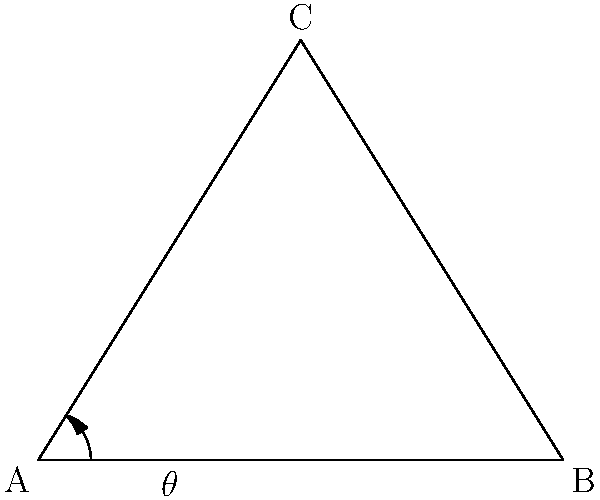In designing an optimal barricade structure, a triangular shape is proposed. The base of the triangle is 10 units long, and the height is 8 units. What is the optimal angle of inclination ($\theta$) for maximum stability against external forces? To find the optimal angle of inclination ($\theta$) for maximum stability:

1. Recognize that the angle of inclination is the angle between the base and the side of the triangle.

2. In a right-angled triangle, tangent of an angle is the ratio of the opposite side to the adjacent side.

3. Here, the height (opposite side) is 8 units, and half of the base (adjacent side) is 5 units.

4. Use the arctangent function to find the angle:

   $$\theta = \arctan(\frac{\text{opposite}}{\text{adjacent}}) = \arctan(\frac{8}{5})$$

5. Calculate:
   $$\theta = \arctan(1.6) \approx 58.0\degree$$

6. Round to the nearest degree for practical application.

This angle provides the optimal balance between stability and material efficiency for the barricade structure.
Answer: $58\degree$ 